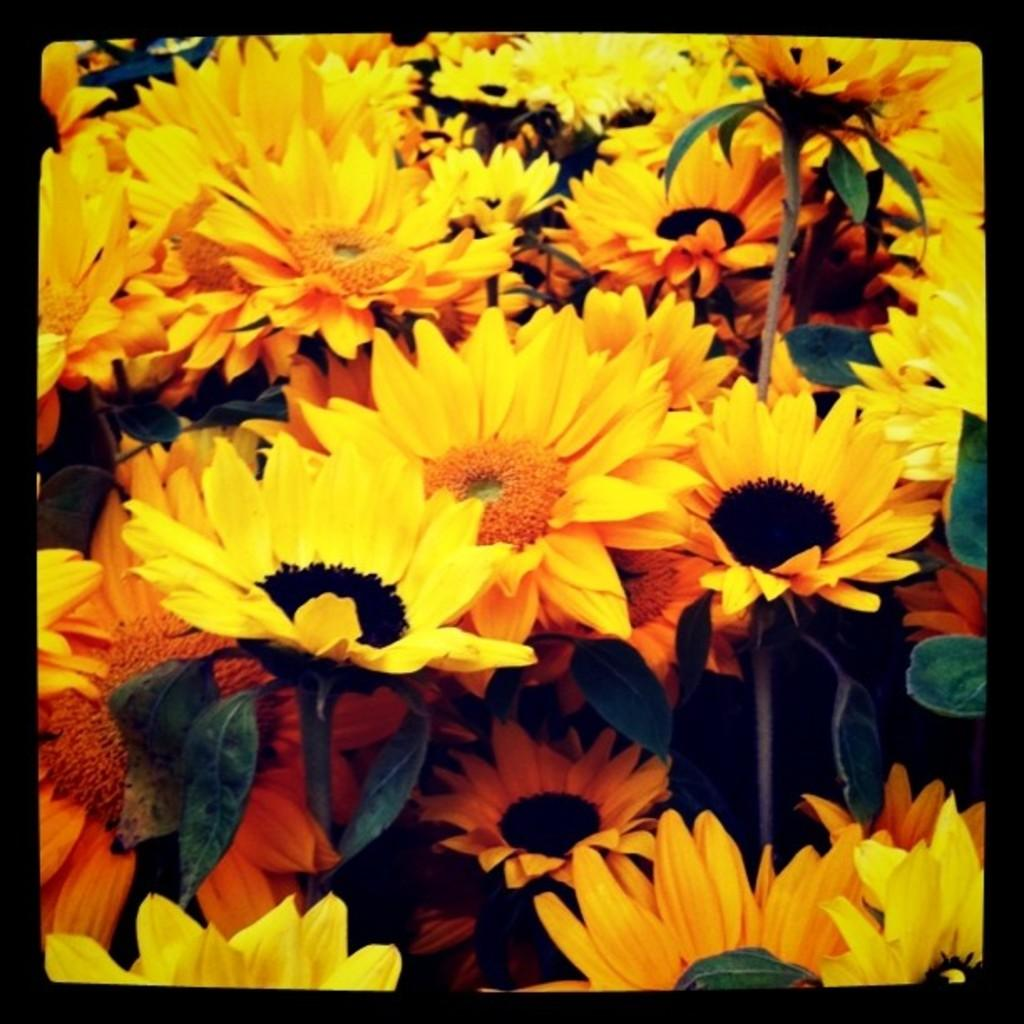What type of flowers are in the image? There are yellow flowers in the image. What else can be seen on the flowers besides the petals? The flowers have leaves. What color is the border of the image? The border of the image is black. What caption is written below the flowers in the image? There is no caption written below the flowers in the image. What offer is being made by the pot in the image? There is no pot present in the image, and therefore no offer can be made. 